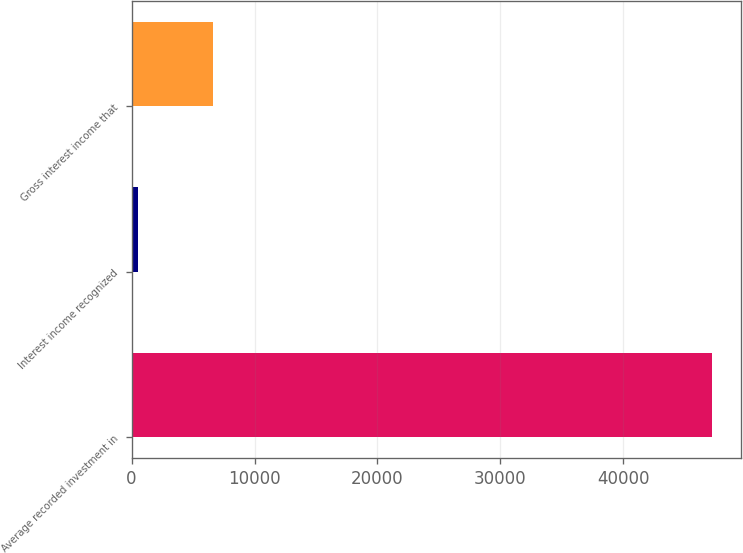Convert chart to OTSL. <chart><loc_0><loc_0><loc_500><loc_500><bar_chart><fcel>Average recorded investment in<fcel>Interest income recognized<fcel>Gross interest income that<nl><fcel>47204<fcel>549<fcel>6619<nl></chart> 